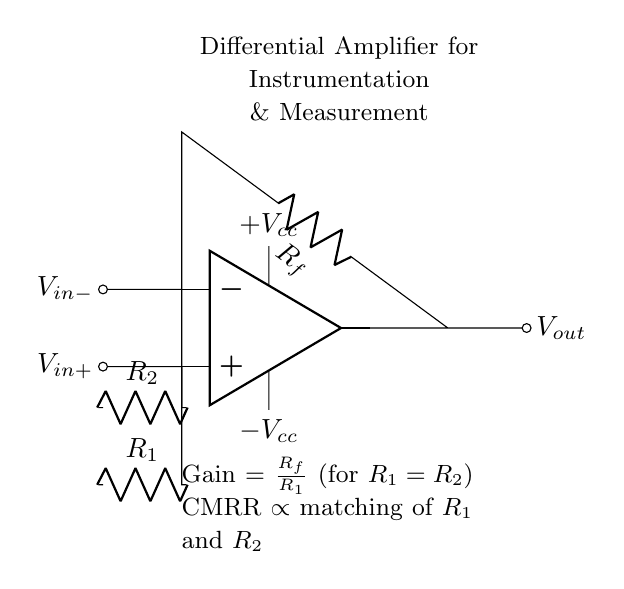What is the function of the op-amp in this circuit? The op-amp serves as a differential amplifier, which amplifies the difference between the voltages at its two inputs, Vin+ and Vin-.
Answer: Differential amplifier What is the gain of the amplifier when R1 is equal to R2? The gain is determined by the formula Gain = Rf/R1. If R1 equals R2, the gain simplifies to 1 when Rf equals R1.
Answer: Rf/R1 What are the power supply voltages for this op-amp? The op-amp requires a dual power supply specified as +Vcc and -Vcc, which provide the necessary voltage levels for operation.
Answer: +Vcc and -Vcc What does CMRR stand for? CMRR stands for Common-Mode Rejection Ratio, which quantifies how well the amplifier rejects common-mode signals present at both inputs.
Answer: Common-Mode Rejection Ratio What components are used to set the input resistance of the amplifier? The input resistances are set by resistors R1 and R2, which are connected to the input terminals of the op-amp.
Answer: R1 and R2 How can the matching of resistors affect the performance of this circuit? The matching of R1 and R2 directly impacts the CMRR; better matching leads to higher CMRR and improved rejection of common-mode signals.
Answer: Improves CMRR 